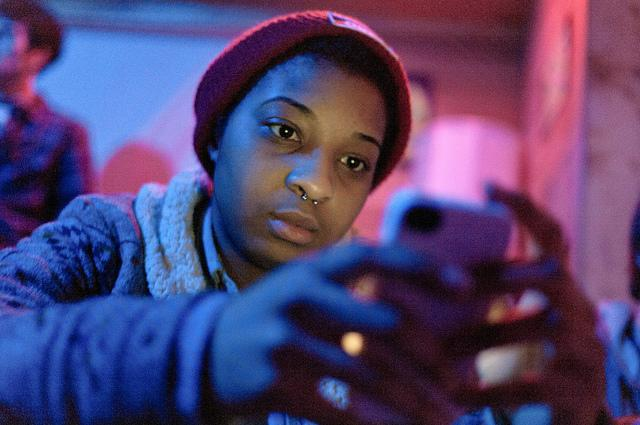What kind of media is she consuming? social media 